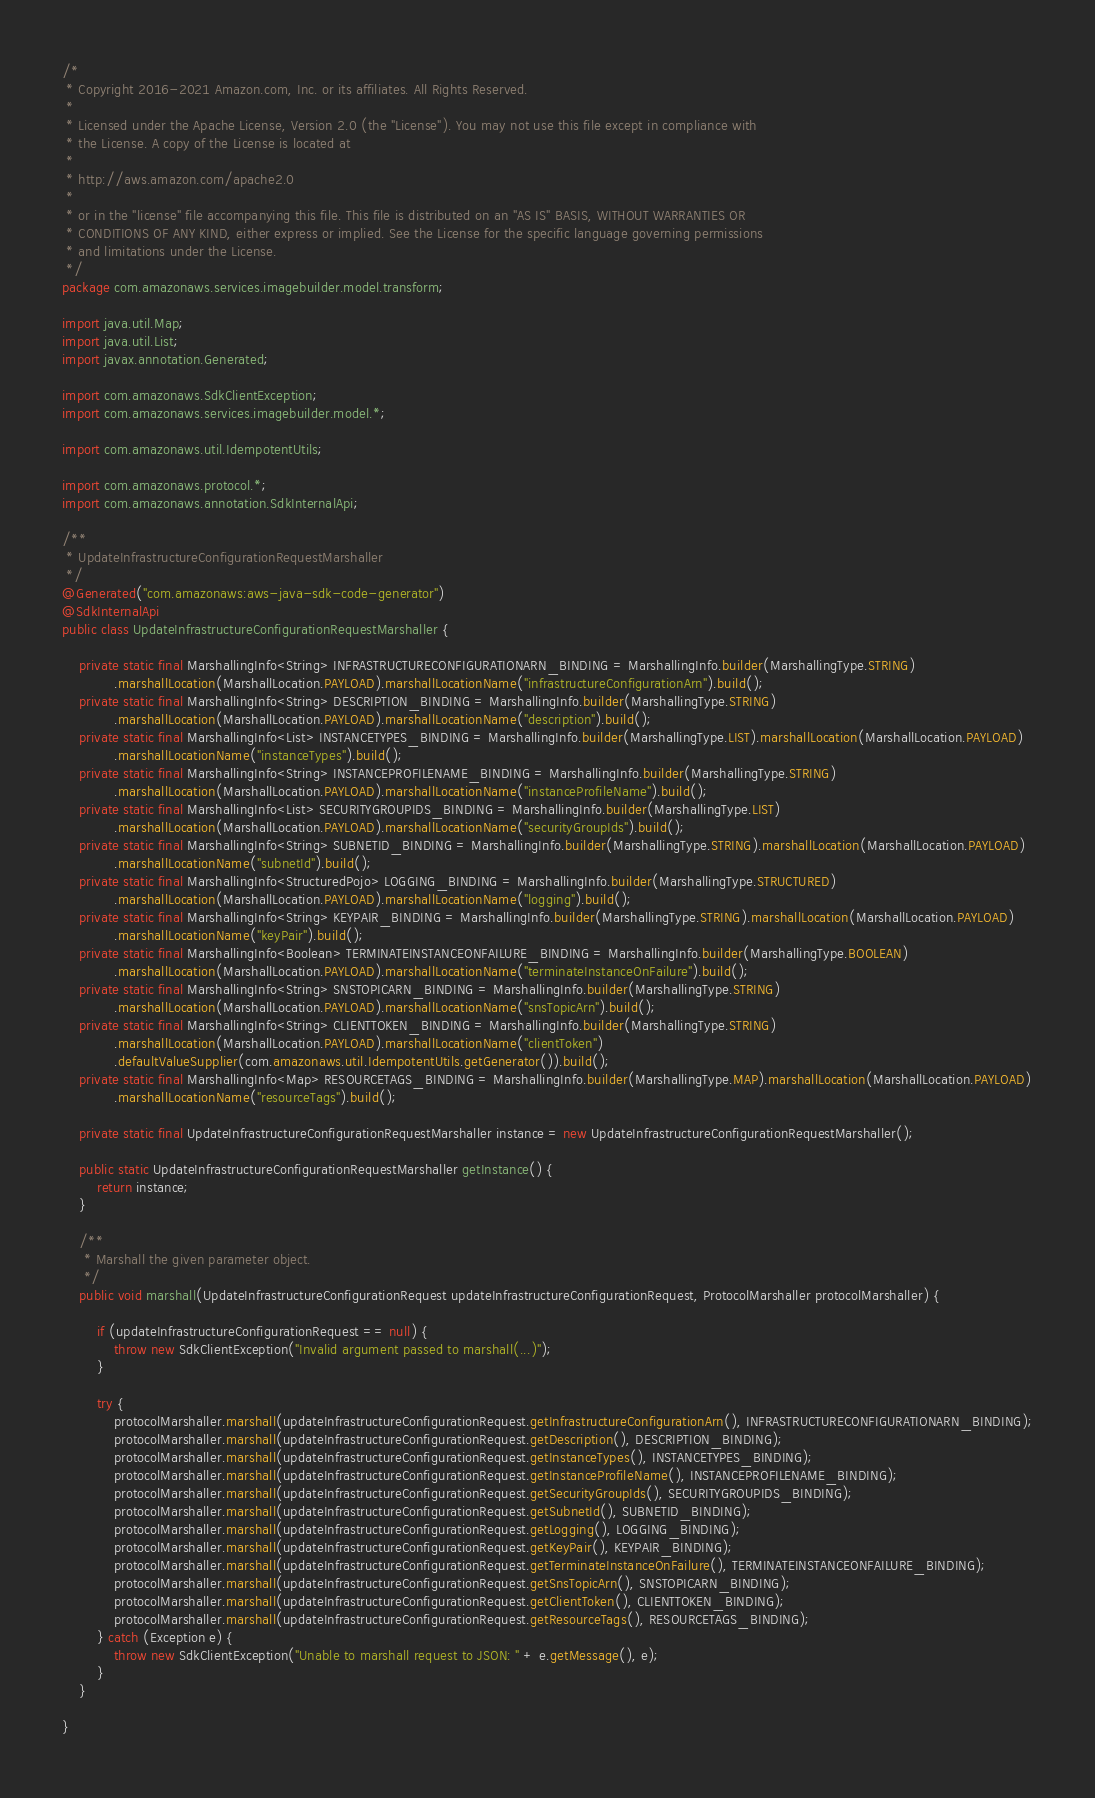Convert code to text. <code><loc_0><loc_0><loc_500><loc_500><_Java_>/*
 * Copyright 2016-2021 Amazon.com, Inc. or its affiliates. All Rights Reserved.
 * 
 * Licensed under the Apache License, Version 2.0 (the "License"). You may not use this file except in compliance with
 * the License. A copy of the License is located at
 * 
 * http://aws.amazon.com/apache2.0
 * 
 * or in the "license" file accompanying this file. This file is distributed on an "AS IS" BASIS, WITHOUT WARRANTIES OR
 * CONDITIONS OF ANY KIND, either express or implied. See the License for the specific language governing permissions
 * and limitations under the License.
 */
package com.amazonaws.services.imagebuilder.model.transform;

import java.util.Map;
import java.util.List;
import javax.annotation.Generated;

import com.amazonaws.SdkClientException;
import com.amazonaws.services.imagebuilder.model.*;

import com.amazonaws.util.IdempotentUtils;

import com.amazonaws.protocol.*;
import com.amazonaws.annotation.SdkInternalApi;

/**
 * UpdateInfrastructureConfigurationRequestMarshaller
 */
@Generated("com.amazonaws:aws-java-sdk-code-generator")
@SdkInternalApi
public class UpdateInfrastructureConfigurationRequestMarshaller {

    private static final MarshallingInfo<String> INFRASTRUCTURECONFIGURATIONARN_BINDING = MarshallingInfo.builder(MarshallingType.STRING)
            .marshallLocation(MarshallLocation.PAYLOAD).marshallLocationName("infrastructureConfigurationArn").build();
    private static final MarshallingInfo<String> DESCRIPTION_BINDING = MarshallingInfo.builder(MarshallingType.STRING)
            .marshallLocation(MarshallLocation.PAYLOAD).marshallLocationName("description").build();
    private static final MarshallingInfo<List> INSTANCETYPES_BINDING = MarshallingInfo.builder(MarshallingType.LIST).marshallLocation(MarshallLocation.PAYLOAD)
            .marshallLocationName("instanceTypes").build();
    private static final MarshallingInfo<String> INSTANCEPROFILENAME_BINDING = MarshallingInfo.builder(MarshallingType.STRING)
            .marshallLocation(MarshallLocation.PAYLOAD).marshallLocationName("instanceProfileName").build();
    private static final MarshallingInfo<List> SECURITYGROUPIDS_BINDING = MarshallingInfo.builder(MarshallingType.LIST)
            .marshallLocation(MarshallLocation.PAYLOAD).marshallLocationName("securityGroupIds").build();
    private static final MarshallingInfo<String> SUBNETID_BINDING = MarshallingInfo.builder(MarshallingType.STRING).marshallLocation(MarshallLocation.PAYLOAD)
            .marshallLocationName("subnetId").build();
    private static final MarshallingInfo<StructuredPojo> LOGGING_BINDING = MarshallingInfo.builder(MarshallingType.STRUCTURED)
            .marshallLocation(MarshallLocation.PAYLOAD).marshallLocationName("logging").build();
    private static final MarshallingInfo<String> KEYPAIR_BINDING = MarshallingInfo.builder(MarshallingType.STRING).marshallLocation(MarshallLocation.PAYLOAD)
            .marshallLocationName("keyPair").build();
    private static final MarshallingInfo<Boolean> TERMINATEINSTANCEONFAILURE_BINDING = MarshallingInfo.builder(MarshallingType.BOOLEAN)
            .marshallLocation(MarshallLocation.PAYLOAD).marshallLocationName("terminateInstanceOnFailure").build();
    private static final MarshallingInfo<String> SNSTOPICARN_BINDING = MarshallingInfo.builder(MarshallingType.STRING)
            .marshallLocation(MarshallLocation.PAYLOAD).marshallLocationName("snsTopicArn").build();
    private static final MarshallingInfo<String> CLIENTTOKEN_BINDING = MarshallingInfo.builder(MarshallingType.STRING)
            .marshallLocation(MarshallLocation.PAYLOAD).marshallLocationName("clientToken")
            .defaultValueSupplier(com.amazonaws.util.IdempotentUtils.getGenerator()).build();
    private static final MarshallingInfo<Map> RESOURCETAGS_BINDING = MarshallingInfo.builder(MarshallingType.MAP).marshallLocation(MarshallLocation.PAYLOAD)
            .marshallLocationName("resourceTags").build();

    private static final UpdateInfrastructureConfigurationRequestMarshaller instance = new UpdateInfrastructureConfigurationRequestMarshaller();

    public static UpdateInfrastructureConfigurationRequestMarshaller getInstance() {
        return instance;
    }

    /**
     * Marshall the given parameter object.
     */
    public void marshall(UpdateInfrastructureConfigurationRequest updateInfrastructureConfigurationRequest, ProtocolMarshaller protocolMarshaller) {

        if (updateInfrastructureConfigurationRequest == null) {
            throw new SdkClientException("Invalid argument passed to marshall(...)");
        }

        try {
            protocolMarshaller.marshall(updateInfrastructureConfigurationRequest.getInfrastructureConfigurationArn(), INFRASTRUCTURECONFIGURATIONARN_BINDING);
            protocolMarshaller.marshall(updateInfrastructureConfigurationRequest.getDescription(), DESCRIPTION_BINDING);
            protocolMarshaller.marshall(updateInfrastructureConfigurationRequest.getInstanceTypes(), INSTANCETYPES_BINDING);
            protocolMarshaller.marshall(updateInfrastructureConfigurationRequest.getInstanceProfileName(), INSTANCEPROFILENAME_BINDING);
            protocolMarshaller.marshall(updateInfrastructureConfigurationRequest.getSecurityGroupIds(), SECURITYGROUPIDS_BINDING);
            protocolMarshaller.marshall(updateInfrastructureConfigurationRequest.getSubnetId(), SUBNETID_BINDING);
            protocolMarshaller.marshall(updateInfrastructureConfigurationRequest.getLogging(), LOGGING_BINDING);
            protocolMarshaller.marshall(updateInfrastructureConfigurationRequest.getKeyPair(), KEYPAIR_BINDING);
            protocolMarshaller.marshall(updateInfrastructureConfigurationRequest.getTerminateInstanceOnFailure(), TERMINATEINSTANCEONFAILURE_BINDING);
            protocolMarshaller.marshall(updateInfrastructureConfigurationRequest.getSnsTopicArn(), SNSTOPICARN_BINDING);
            protocolMarshaller.marshall(updateInfrastructureConfigurationRequest.getClientToken(), CLIENTTOKEN_BINDING);
            protocolMarshaller.marshall(updateInfrastructureConfigurationRequest.getResourceTags(), RESOURCETAGS_BINDING);
        } catch (Exception e) {
            throw new SdkClientException("Unable to marshall request to JSON: " + e.getMessage(), e);
        }
    }

}
</code> 